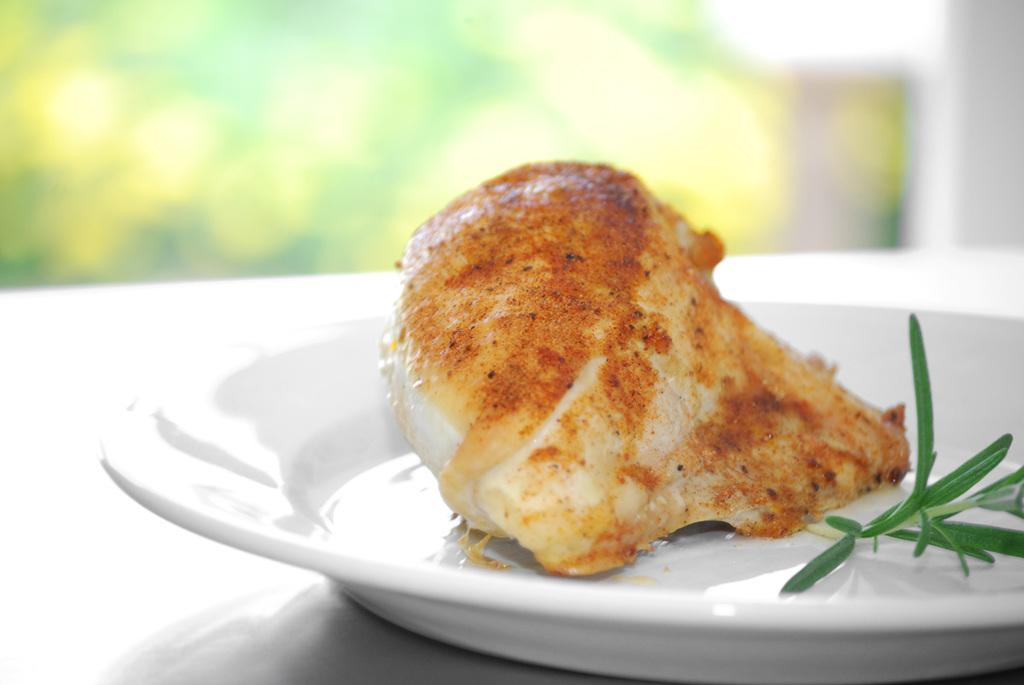What piece of furniture is present in the image? There is a table in the image. What is placed on the table? There is a plate on the table. What is on the plate? There is a food item on the plate. What type of plant material is visible in the image? There is a leaf in the image. How would you describe the background of the image? The background appears blurry. What type of grass is growing on the plate in the image? There is no grass present on the plate in the image; it contains a food item. 